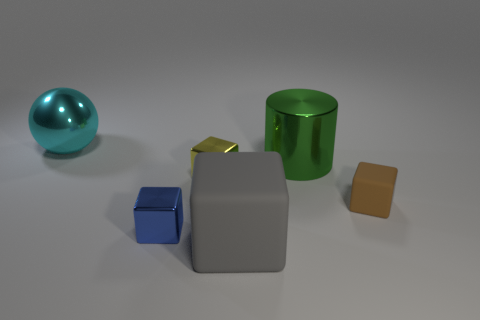Add 3 tiny blue rubber cubes. How many objects exist? 9 Subtract all blue cubes. How many cubes are left? 3 Subtract all gray blocks. How many blocks are left? 3 Subtract all cylinders. How many objects are left? 5 Add 2 tiny purple cubes. How many tiny purple cubes exist? 2 Subtract 0 red balls. How many objects are left? 6 Subtract all gray cubes. Subtract all yellow balls. How many cubes are left? 3 Subtract all small blue cubes. Subtract all cyan metal objects. How many objects are left? 4 Add 2 small blue things. How many small blue things are left? 3 